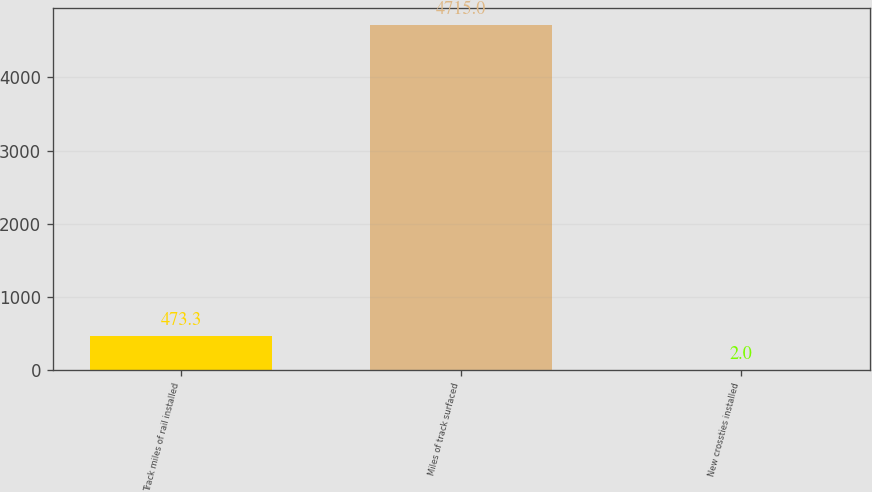Convert chart. <chart><loc_0><loc_0><loc_500><loc_500><bar_chart><fcel>Track miles of rail installed<fcel>Miles of track surfaced<fcel>New crossties installed<nl><fcel>473.3<fcel>4715<fcel>2<nl></chart> 